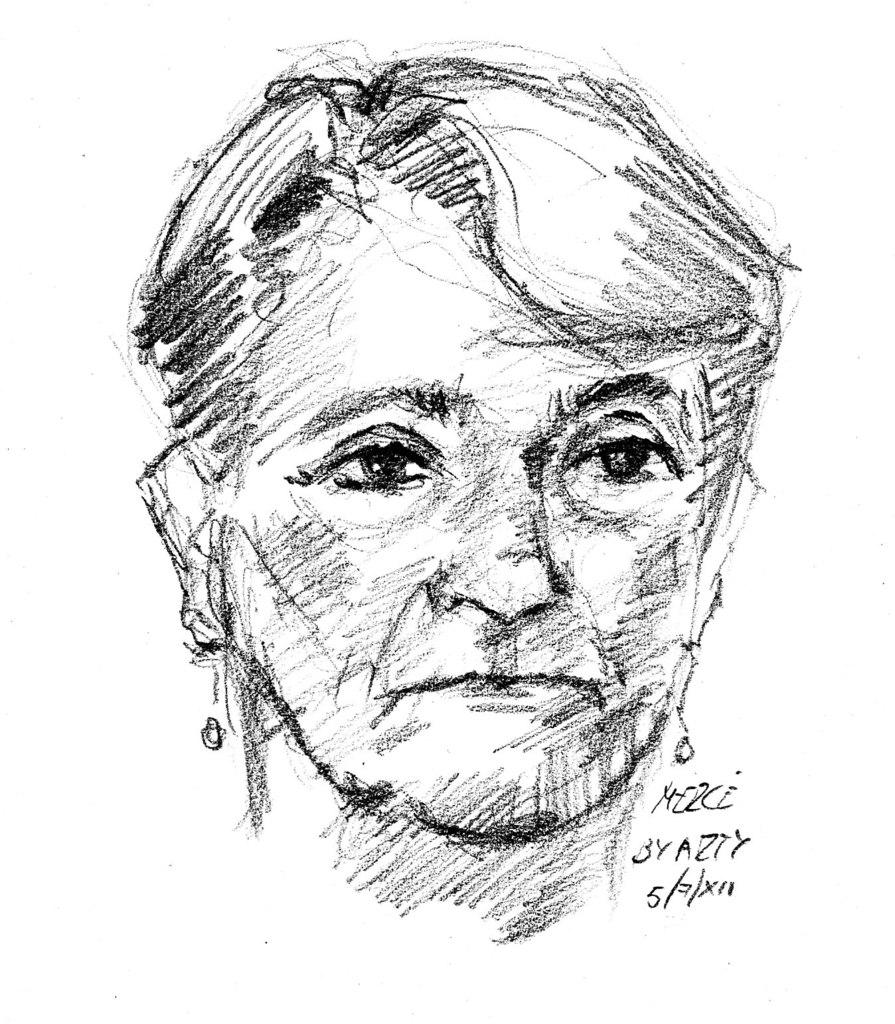What is depicted in the image? There is a drawing of a person's face in the image. What else can be seen in the image besides the drawing? There is text written on the image. What type of jelly is being used to create the drawing in the image? There is no jelly present in the image; it is a drawing of a person's face with text written on it. 